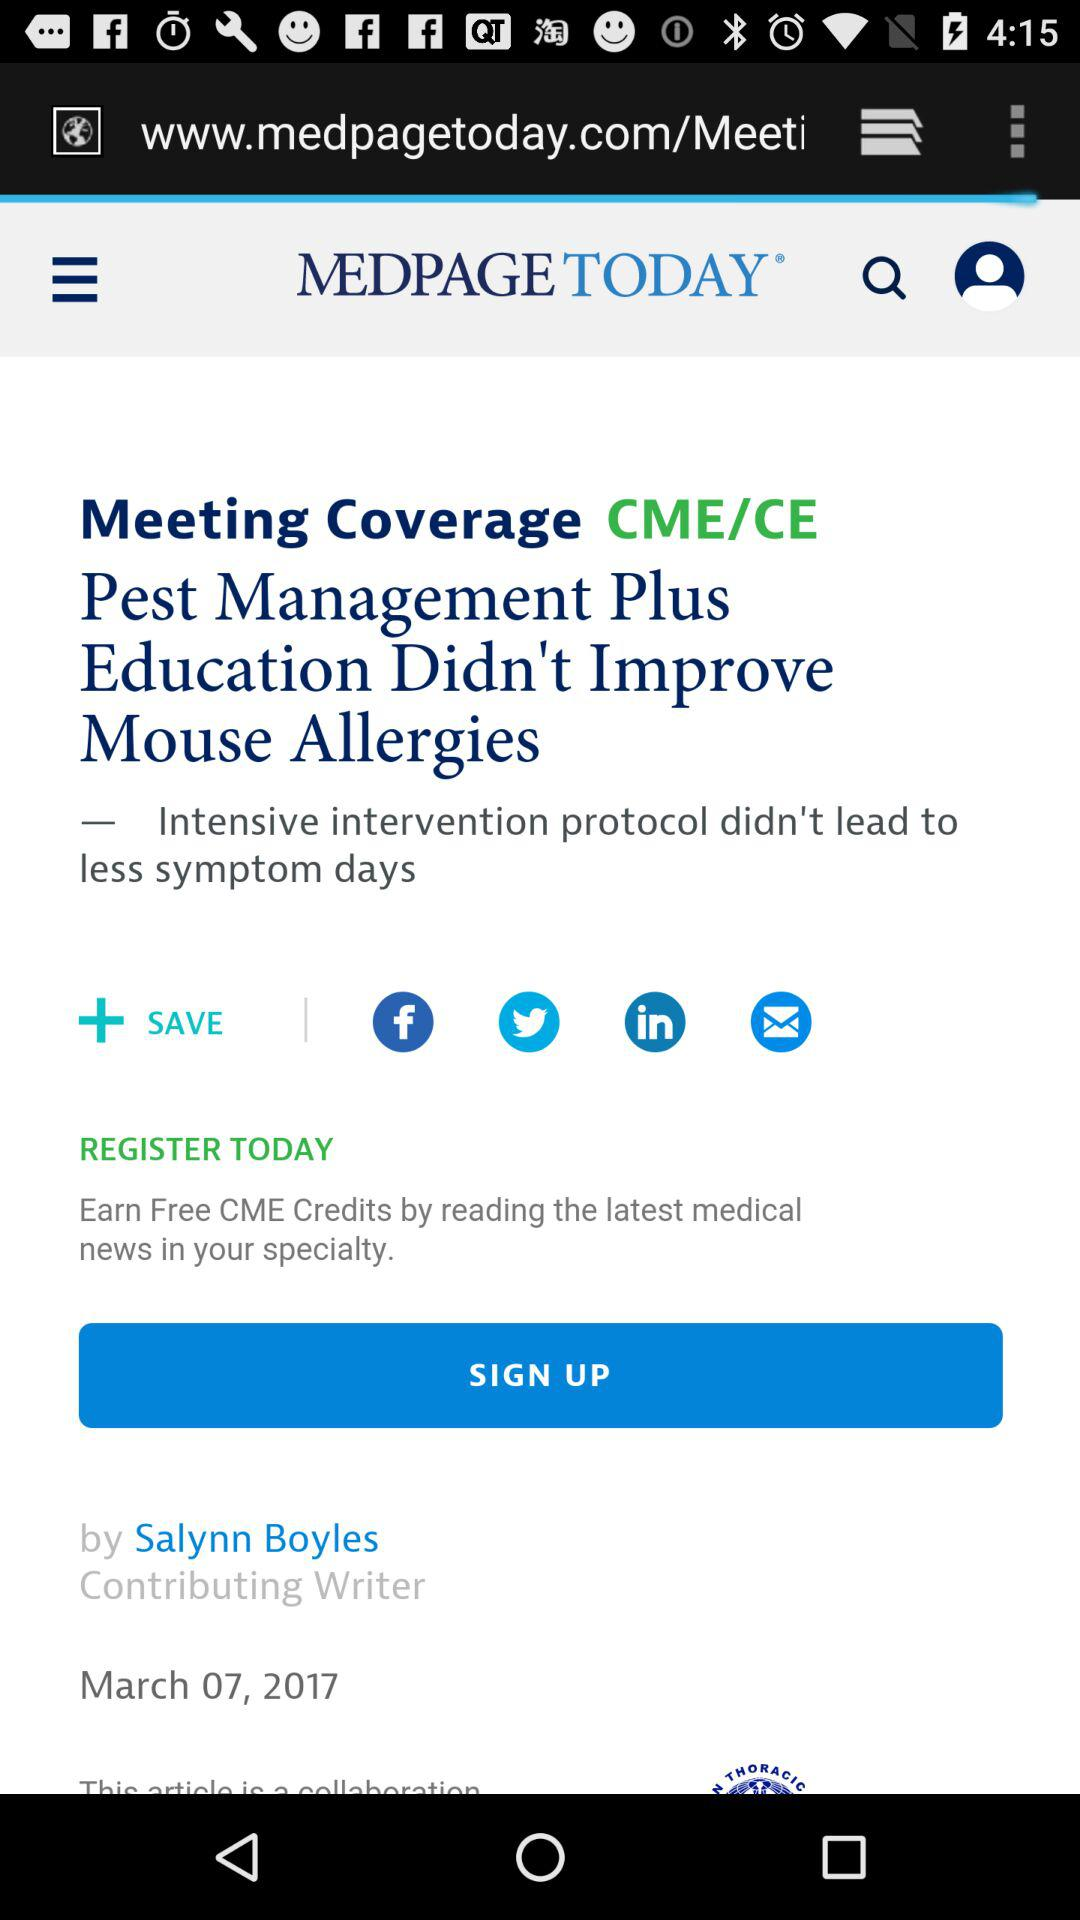What is the application name? The application name is "MEDPAGE TODAY". 